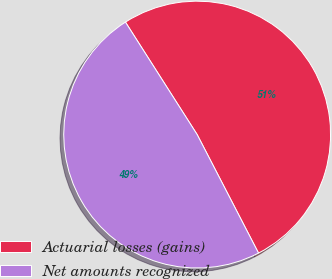Convert chart. <chart><loc_0><loc_0><loc_500><loc_500><pie_chart><fcel>Actuarial losses (gains)<fcel>Net amounts recognized<nl><fcel>51.43%<fcel>48.57%<nl></chart> 